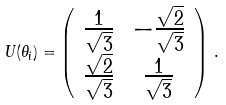Convert formula to latex. <formula><loc_0><loc_0><loc_500><loc_500>U ( \theta _ { i } ) = \left ( \begin{array} { c c } \frac { 1 } { \sqrt { 3 } } & - \frac { \sqrt { 2 } } { \sqrt { 3 } } \\ \frac { \sqrt { 2 } } { \sqrt { 3 } } & \frac { 1 } { \sqrt { 3 } } \\ \end{array} \right ) \, .</formula> 